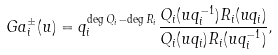Convert formula to latex. <formula><loc_0><loc_0><loc_500><loc_500>\ G a _ { i } ^ { \pm } ( u ) = q _ { i } ^ { \deg Q _ { i } - \deg R _ { i } } \frac { Q _ { i } ( u q _ { i } ^ { - 1 } ) R _ { i } ( u q _ { i } ) } { Q _ { i } ( u q _ { i } ) R _ { i } ( u q _ { i } ^ { - 1 } ) } ,</formula> 